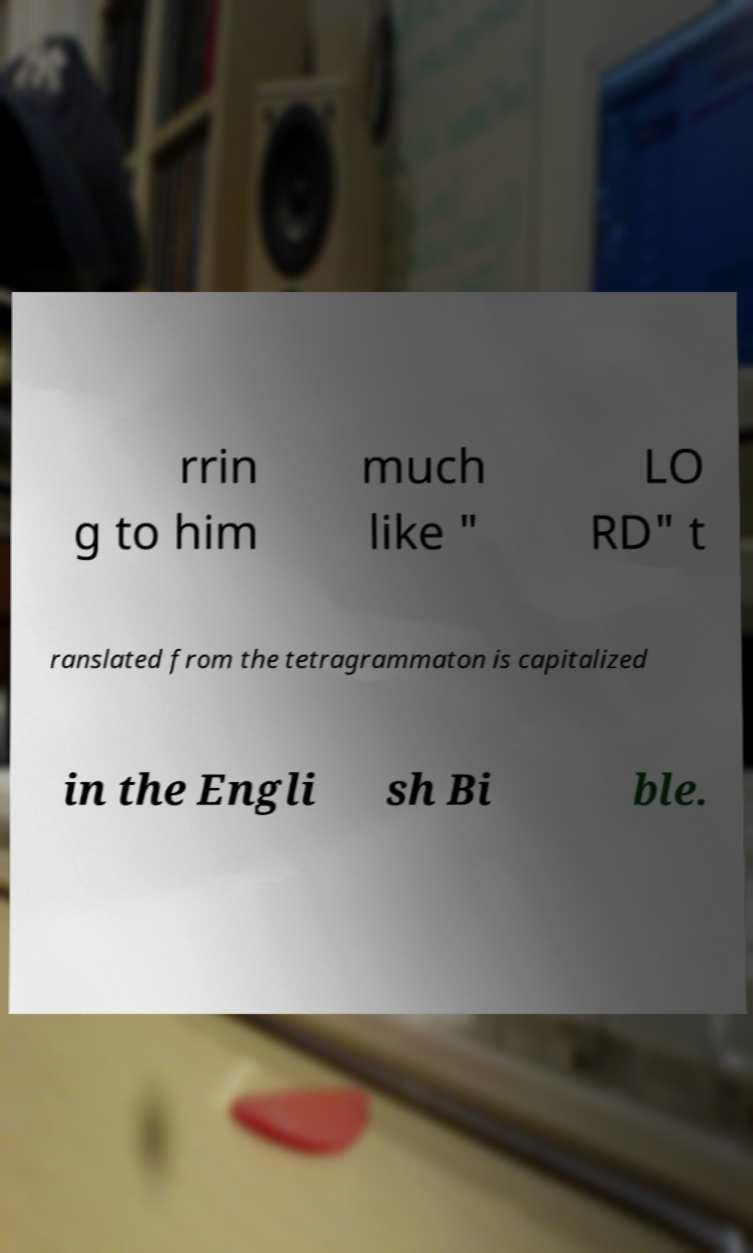For documentation purposes, I need the text within this image transcribed. Could you provide that? rrin g to him much like " LO RD" t ranslated from the tetragrammaton is capitalized in the Engli sh Bi ble. 